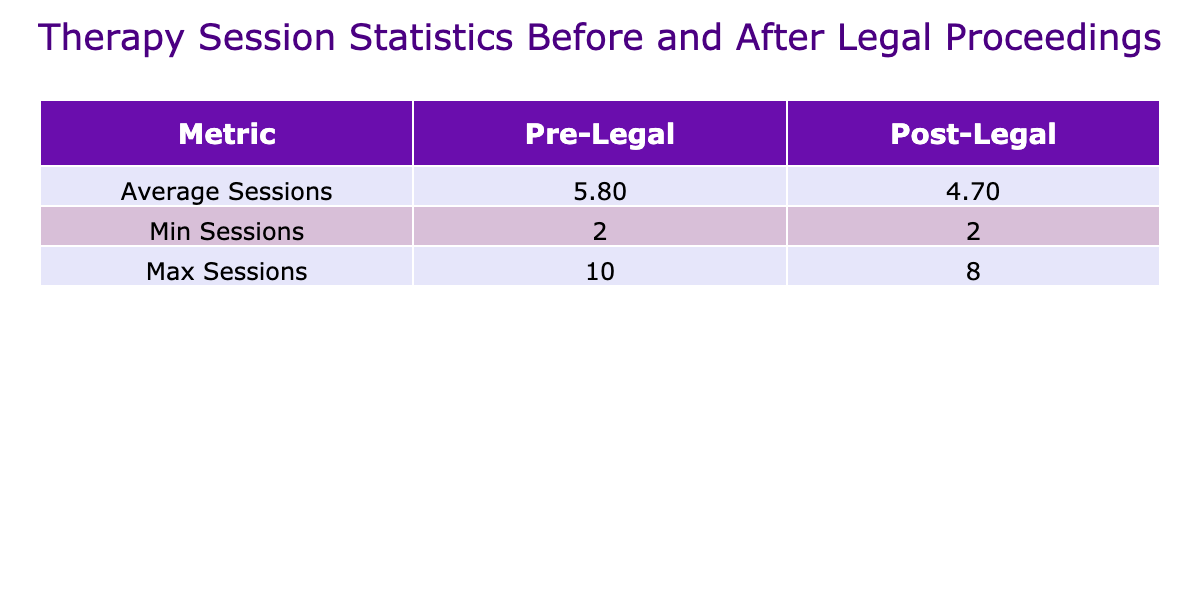What is the average number of therapy sessions attended by clients before legal proceedings? To find the average number of therapy sessions attended before legal proceedings, we look at the 'Pre-Legal' column in the table. The counts of sessions are: 8, 4, 10, 5, 3, 7, 6, 2, 9, and 4. By summing these values (8 + 4 + 10 + 5 + 3 + 7 + 6 + 2 + 9 + 4 = 58) and dividing by the total number of clients (10), we get an average of 58/10 = 5.8 sessions.
Answer: 5.8 What is the minimum number of therapy sessions attended by clients after legal proceedings? We check the 'Post-Legal' column for the minimum value. The counts of sessions after legal proceedings are: 6, 5, 3, 7, 4, 2, 8, 3, 5, and 4. The smallest value among these is 2, therefore, the minimum number of sessions after legal proceedings is 2.
Answer: 2 Is the average number of therapy sessions attended post-legal proceedings greater than the average before legal proceedings? We first calculate the averages: the average pre-legal is 5.8 and for post-legal sessions it is (6 + 5 + 3 + 7 + 4 + 2 + 8 + 3 + 5 + 4 = 47) divided by 10 gives 4.7. Since 5.8 is greater than 4.7, the average pre-legal is indeed greater than post-legal sessions.
Answer: Yes How many clients attended an equal number of therapy sessions both before and after legal proceedings? We examine 'Pre-Legal' and 'Post-Legal' sessions for equality. The counts are: 8, 6, 10, 5, 3, 7, 6, 2, 9, 4 for pre-legal and 6, 5, 3, 7, 4, 2, 8, 3, 5, 4 for post-legal. Comparing both lists, only Charles Wilson attended 4 sessions before and after. Therefore, only 1 client attended the same number of sessions before and after.
Answer: 1 What is the average difference in therapy sessions attended before and after legal proceedings? To find the average difference, we first compute the differences for each client: (8-6), (4-5), (10-3), (5-7), (3-4), (7-2), (6-8), (2-3), (9-5), (4-4) which yields: 2, -1, 7, -2, -1, 5, -2, -1, 4, 0. We sum these differences (2 - 1 + 7 - 2 - 1 + 5 - 2 - 1 + 4 + 0 = 12) and divide by 10 giving an average of 1.2. Hence, the average difference in attended sessions is 1.2.
Answer: 1.2 